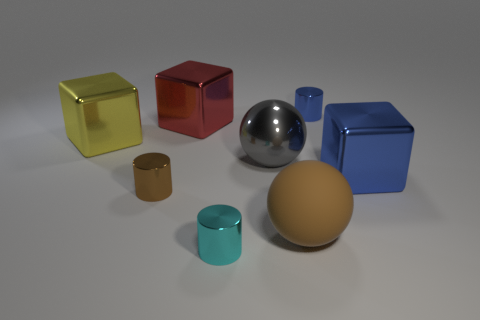Are there any other things that have the same material as the brown sphere?
Offer a terse response. No. How many large things are yellow matte cylinders or brown things?
Ensure brevity in your answer.  1. How many tiny brown objects have the same shape as the small blue metallic thing?
Make the answer very short. 1. What material is the blue object behind the big thing that is behind the yellow thing made of?
Give a very brief answer. Metal. What size is the cylinder to the left of the cyan cylinder?
Ensure brevity in your answer.  Small. What number of blue things are big matte things or metallic cubes?
Your answer should be very brief. 1. There is a yellow object that is the same shape as the large red shiny thing; what is its material?
Offer a terse response. Metal. Are there the same number of large brown rubber balls that are left of the red block and large blue blocks?
Ensure brevity in your answer.  No. What size is the object that is in front of the blue metallic cylinder and right of the big matte ball?
Offer a terse response. Large. Is there any other thing of the same color as the large rubber sphere?
Give a very brief answer. Yes. 